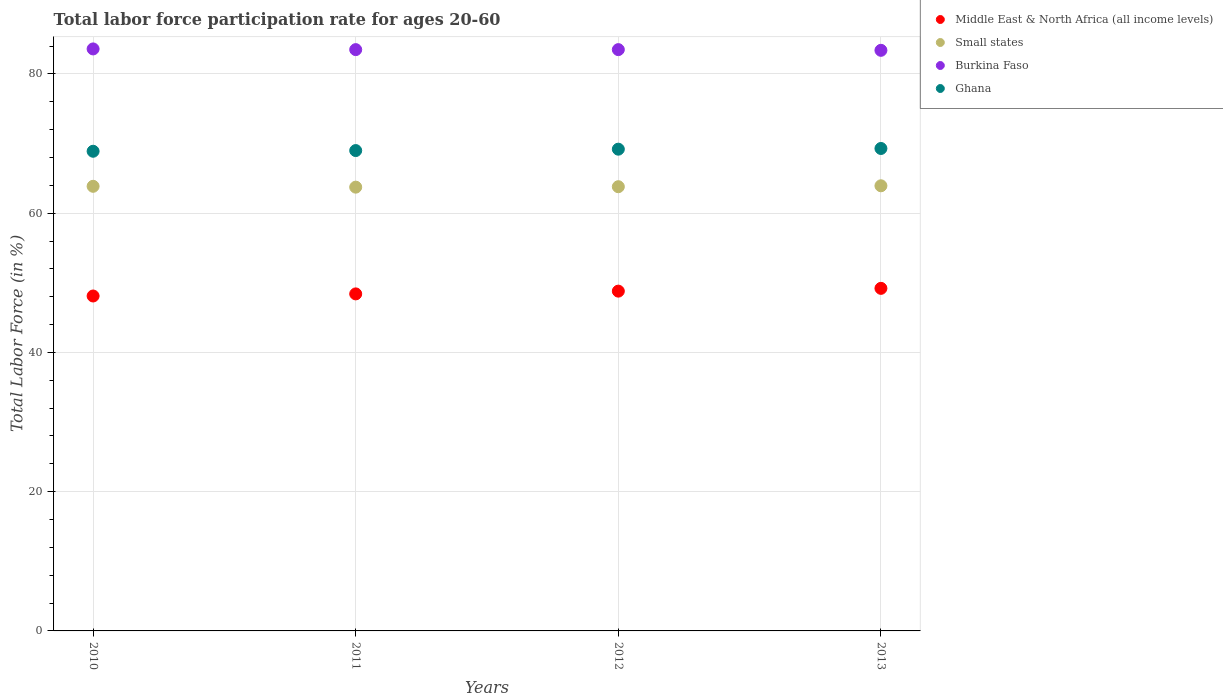What is the labor force participation rate in Ghana in 2012?
Give a very brief answer. 69.2. Across all years, what is the maximum labor force participation rate in Middle East & North Africa (all income levels)?
Offer a terse response. 49.21. Across all years, what is the minimum labor force participation rate in Ghana?
Provide a succinct answer. 68.9. In which year was the labor force participation rate in Middle East & North Africa (all income levels) maximum?
Your answer should be very brief. 2013. What is the total labor force participation rate in Ghana in the graph?
Make the answer very short. 276.4. What is the difference between the labor force participation rate in Burkina Faso in 2012 and that in 2013?
Make the answer very short. 0.1. What is the difference between the labor force participation rate in Small states in 2010 and the labor force participation rate in Middle East & North Africa (all income levels) in 2012?
Provide a succinct answer. 15.06. What is the average labor force participation rate in Small states per year?
Provide a succinct answer. 63.84. In the year 2010, what is the difference between the labor force participation rate in Small states and labor force participation rate in Ghana?
Make the answer very short. -5.03. What is the ratio of the labor force participation rate in Middle East & North Africa (all income levels) in 2010 to that in 2011?
Your answer should be very brief. 0.99. What is the difference between the highest and the second highest labor force participation rate in Small states?
Offer a very short reply. 0.07. What is the difference between the highest and the lowest labor force participation rate in Burkina Faso?
Offer a very short reply. 0.2. In how many years, is the labor force participation rate in Small states greater than the average labor force participation rate in Small states taken over all years?
Your answer should be very brief. 2. Is the sum of the labor force participation rate in Small states in 2010 and 2013 greater than the maximum labor force participation rate in Middle East & North Africa (all income levels) across all years?
Your answer should be compact. Yes. Is it the case that in every year, the sum of the labor force participation rate in Burkina Faso and labor force participation rate in Small states  is greater than the labor force participation rate in Middle East & North Africa (all income levels)?
Your answer should be compact. Yes. Does the labor force participation rate in Middle East & North Africa (all income levels) monotonically increase over the years?
Offer a very short reply. Yes. Is the labor force participation rate in Burkina Faso strictly greater than the labor force participation rate in Middle East & North Africa (all income levels) over the years?
Provide a succinct answer. Yes. Is the labor force participation rate in Burkina Faso strictly less than the labor force participation rate in Small states over the years?
Your answer should be very brief. No. How many dotlines are there?
Provide a succinct answer. 4. What is the difference between two consecutive major ticks on the Y-axis?
Offer a very short reply. 20. Does the graph contain any zero values?
Offer a very short reply. No. Where does the legend appear in the graph?
Offer a very short reply. Top right. What is the title of the graph?
Give a very brief answer. Total labor force participation rate for ages 20-60. What is the label or title of the X-axis?
Your answer should be very brief. Years. What is the label or title of the Y-axis?
Offer a terse response. Total Labor Force (in %). What is the Total Labor Force (in %) of Middle East & North Africa (all income levels) in 2010?
Offer a very short reply. 48.11. What is the Total Labor Force (in %) of Small states in 2010?
Your answer should be very brief. 63.87. What is the Total Labor Force (in %) of Burkina Faso in 2010?
Ensure brevity in your answer.  83.6. What is the Total Labor Force (in %) in Ghana in 2010?
Make the answer very short. 68.9. What is the Total Labor Force (in %) in Middle East & North Africa (all income levels) in 2011?
Ensure brevity in your answer.  48.41. What is the Total Labor Force (in %) in Small states in 2011?
Provide a short and direct response. 63.75. What is the Total Labor Force (in %) in Burkina Faso in 2011?
Your answer should be very brief. 83.5. What is the Total Labor Force (in %) of Ghana in 2011?
Make the answer very short. 69. What is the Total Labor Force (in %) of Middle East & North Africa (all income levels) in 2012?
Make the answer very short. 48.81. What is the Total Labor Force (in %) of Small states in 2012?
Offer a very short reply. 63.81. What is the Total Labor Force (in %) of Burkina Faso in 2012?
Keep it short and to the point. 83.5. What is the Total Labor Force (in %) of Ghana in 2012?
Offer a very short reply. 69.2. What is the Total Labor Force (in %) in Middle East & North Africa (all income levels) in 2013?
Your answer should be very brief. 49.21. What is the Total Labor Force (in %) in Small states in 2013?
Give a very brief answer. 63.94. What is the Total Labor Force (in %) in Burkina Faso in 2013?
Your answer should be compact. 83.4. What is the Total Labor Force (in %) in Ghana in 2013?
Give a very brief answer. 69.3. Across all years, what is the maximum Total Labor Force (in %) in Middle East & North Africa (all income levels)?
Keep it short and to the point. 49.21. Across all years, what is the maximum Total Labor Force (in %) of Small states?
Keep it short and to the point. 63.94. Across all years, what is the maximum Total Labor Force (in %) in Burkina Faso?
Give a very brief answer. 83.6. Across all years, what is the maximum Total Labor Force (in %) of Ghana?
Keep it short and to the point. 69.3. Across all years, what is the minimum Total Labor Force (in %) of Middle East & North Africa (all income levels)?
Provide a succinct answer. 48.11. Across all years, what is the minimum Total Labor Force (in %) in Small states?
Provide a short and direct response. 63.75. Across all years, what is the minimum Total Labor Force (in %) of Burkina Faso?
Provide a short and direct response. 83.4. Across all years, what is the minimum Total Labor Force (in %) in Ghana?
Ensure brevity in your answer.  68.9. What is the total Total Labor Force (in %) of Middle East & North Africa (all income levels) in the graph?
Provide a succinct answer. 194.54. What is the total Total Labor Force (in %) in Small states in the graph?
Offer a very short reply. 255.36. What is the total Total Labor Force (in %) in Burkina Faso in the graph?
Give a very brief answer. 334. What is the total Total Labor Force (in %) in Ghana in the graph?
Keep it short and to the point. 276.4. What is the difference between the Total Labor Force (in %) in Middle East & North Africa (all income levels) in 2010 and that in 2011?
Provide a succinct answer. -0.3. What is the difference between the Total Labor Force (in %) of Small states in 2010 and that in 2011?
Your answer should be compact. 0.12. What is the difference between the Total Labor Force (in %) in Middle East & North Africa (all income levels) in 2010 and that in 2012?
Give a very brief answer. -0.7. What is the difference between the Total Labor Force (in %) in Small states in 2010 and that in 2012?
Give a very brief answer. 0.06. What is the difference between the Total Labor Force (in %) of Middle East & North Africa (all income levels) in 2010 and that in 2013?
Offer a very short reply. -1.1. What is the difference between the Total Labor Force (in %) in Small states in 2010 and that in 2013?
Your answer should be very brief. -0.07. What is the difference between the Total Labor Force (in %) of Burkina Faso in 2010 and that in 2013?
Provide a succinct answer. 0.2. What is the difference between the Total Labor Force (in %) of Ghana in 2010 and that in 2013?
Your response must be concise. -0.4. What is the difference between the Total Labor Force (in %) of Middle East & North Africa (all income levels) in 2011 and that in 2012?
Offer a terse response. -0.4. What is the difference between the Total Labor Force (in %) in Small states in 2011 and that in 2012?
Make the answer very short. -0.06. What is the difference between the Total Labor Force (in %) in Burkina Faso in 2011 and that in 2012?
Offer a terse response. 0. What is the difference between the Total Labor Force (in %) in Middle East & North Africa (all income levels) in 2011 and that in 2013?
Keep it short and to the point. -0.8. What is the difference between the Total Labor Force (in %) in Small states in 2011 and that in 2013?
Provide a succinct answer. -0.2. What is the difference between the Total Labor Force (in %) in Burkina Faso in 2011 and that in 2013?
Offer a very short reply. 0.1. What is the difference between the Total Labor Force (in %) of Ghana in 2011 and that in 2013?
Provide a short and direct response. -0.3. What is the difference between the Total Labor Force (in %) in Middle East & North Africa (all income levels) in 2012 and that in 2013?
Ensure brevity in your answer.  -0.4. What is the difference between the Total Labor Force (in %) in Small states in 2012 and that in 2013?
Make the answer very short. -0.13. What is the difference between the Total Labor Force (in %) of Burkina Faso in 2012 and that in 2013?
Your answer should be compact. 0.1. What is the difference between the Total Labor Force (in %) in Ghana in 2012 and that in 2013?
Keep it short and to the point. -0.1. What is the difference between the Total Labor Force (in %) in Middle East & North Africa (all income levels) in 2010 and the Total Labor Force (in %) in Small states in 2011?
Your answer should be compact. -15.64. What is the difference between the Total Labor Force (in %) of Middle East & North Africa (all income levels) in 2010 and the Total Labor Force (in %) of Burkina Faso in 2011?
Keep it short and to the point. -35.39. What is the difference between the Total Labor Force (in %) in Middle East & North Africa (all income levels) in 2010 and the Total Labor Force (in %) in Ghana in 2011?
Make the answer very short. -20.89. What is the difference between the Total Labor Force (in %) in Small states in 2010 and the Total Labor Force (in %) in Burkina Faso in 2011?
Provide a succinct answer. -19.63. What is the difference between the Total Labor Force (in %) in Small states in 2010 and the Total Labor Force (in %) in Ghana in 2011?
Offer a very short reply. -5.13. What is the difference between the Total Labor Force (in %) in Middle East & North Africa (all income levels) in 2010 and the Total Labor Force (in %) in Small states in 2012?
Your response must be concise. -15.7. What is the difference between the Total Labor Force (in %) in Middle East & North Africa (all income levels) in 2010 and the Total Labor Force (in %) in Burkina Faso in 2012?
Keep it short and to the point. -35.39. What is the difference between the Total Labor Force (in %) in Middle East & North Africa (all income levels) in 2010 and the Total Labor Force (in %) in Ghana in 2012?
Your response must be concise. -21.09. What is the difference between the Total Labor Force (in %) in Small states in 2010 and the Total Labor Force (in %) in Burkina Faso in 2012?
Ensure brevity in your answer.  -19.63. What is the difference between the Total Labor Force (in %) of Small states in 2010 and the Total Labor Force (in %) of Ghana in 2012?
Offer a terse response. -5.33. What is the difference between the Total Labor Force (in %) of Middle East & North Africa (all income levels) in 2010 and the Total Labor Force (in %) of Small states in 2013?
Ensure brevity in your answer.  -15.83. What is the difference between the Total Labor Force (in %) in Middle East & North Africa (all income levels) in 2010 and the Total Labor Force (in %) in Burkina Faso in 2013?
Provide a succinct answer. -35.29. What is the difference between the Total Labor Force (in %) of Middle East & North Africa (all income levels) in 2010 and the Total Labor Force (in %) of Ghana in 2013?
Provide a succinct answer. -21.19. What is the difference between the Total Labor Force (in %) in Small states in 2010 and the Total Labor Force (in %) in Burkina Faso in 2013?
Make the answer very short. -19.53. What is the difference between the Total Labor Force (in %) in Small states in 2010 and the Total Labor Force (in %) in Ghana in 2013?
Provide a short and direct response. -5.43. What is the difference between the Total Labor Force (in %) in Burkina Faso in 2010 and the Total Labor Force (in %) in Ghana in 2013?
Your response must be concise. 14.3. What is the difference between the Total Labor Force (in %) in Middle East & North Africa (all income levels) in 2011 and the Total Labor Force (in %) in Small states in 2012?
Offer a terse response. -15.4. What is the difference between the Total Labor Force (in %) in Middle East & North Africa (all income levels) in 2011 and the Total Labor Force (in %) in Burkina Faso in 2012?
Provide a succinct answer. -35.09. What is the difference between the Total Labor Force (in %) in Middle East & North Africa (all income levels) in 2011 and the Total Labor Force (in %) in Ghana in 2012?
Offer a very short reply. -20.79. What is the difference between the Total Labor Force (in %) in Small states in 2011 and the Total Labor Force (in %) in Burkina Faso in 2012?
Give a very brief answer. -19.75. What is the difference between the Total Labor Force (in %) of Small states in 2011 and the Total Labor Force (in %) of Ghana in 2012?
Provide a succinct answer. -5.45. What is the difference between the Total Labor Force (in %) of Burkina Faso in 2011 and the Total Labor Force (in %) of Ghana in 2012?
Provide a short and direct response. 14.3. What is the difference between the Total Labor Force (in %) in Middle East & North Africa (all income levels) in 2011 and the Total Labor Force (in %) in Small states in 2013?
Your answer should be very brief. -15.53. What is the difference between the Total Labor Force (in %) in Middle East & North Africa (all income levels) in 2011 and the Total Labor Force (in %) in Burkina Faso in 2013?
Give a very brief answer. -34.99. What is the difference between the Total Labor Force (in %) of Middle East & North Africa (all income levels) in 2011 and the Total Labor Force (in %) of Ghana in 2013?
Provide a succinct answer. -20.89. What is the difference between the Total Labor Force (in %) of Small states in 2011 and the Total Labor Force (in %) of Burkina Faso in 2013?
Offer a very short reply. -19.65. What is the difference between the Total Labor Force (in %) in Small states in 2011 and the Total Labor Force (in %) in Ghana in 2013?
Your answer should be very brief. -5.55. What is the difference between the Total Labor Force (in %) of Middle East & North Africa (all income levels) in 2012 and the Total Labor Force (in %) of Small states in 2013?
Your answer should be very brief. -15.13. What is the difference between the Total Labor Force (in %) in Middle East & North Africa (all income levels) in 2012 and the Total Labor Force (in %) in Burkina Faso in 2013?
Provide a succinct answer. -34.59. What is the difference between the Total Labor Force (in %) in Middle East & North Africa (all income levels) in 2012 and the Total Labor Force (in %) in Ghana in 2013?
Offer a terse response. -20.49. What is the difference between the Total Labor Force (in %) of Small states in 2012 and the Total Labor Force (in %) of Burkina Faso in 2013?
Provide a short and direct response. -19.59. What is the difference between the Total Labor Force (in %) in Small states in 2012 and the Total Labor Force (in %) in Ghana in 2013?
Your answer should be compact. -5.49. What is the average Total Labor Force (in %) in Middle East & North Africa (all income levels) per year?
Ensure brevity in your answer.  48.63. What is the average Total Labor Force (in %) of Small states per year?
Give a very brief answer. 63.84. What is the average Total Labor Force (in %) of Burkina Faso per year?
Provide a short and direct response. 83.5. What is the average Total Labor Force (in %) of Ghana per year?
Make the answer very short. 69.1. In the year 2010, what is the difference between the Total Labor Force (in %) of Middle East & North Africa (all income levels) and Total Labor Force (in %) of Small states?
Your answer should be very brief. -15.76. In the year 2010, what is the difference between the Total Labor Force (in %) in Middle East & North Africa (all income levels) and Total Labor Force (in %) in Burkina Faso?
Provide a succinct answer. -35.49. In the year 2010, what is the difference between the Total Labor Force (in %) in Middle East & North Africa (all income levels) and Total Labor Force (in %) in Ghana?
Your answer should be very brief. -20.79. In the year 2010, what is the difference between the Total Labor Force (in %) in Small states and Total Labor Force (in %) in Burkina Faso?
Ensure brevity in your answer.  -19.73. In the year 2010, what is the difference between the Total Labor Force (in %) of Small states and Total Labor Force (in %) of Ghana?
Offer a terse response. -5.03. In the year 2010, what is the difference between the Total Labor Force (in %) in Burkina Faso and Total Labor Force (in %) in Ghana?
Your response must be concise. 14.7. In the year 2011, what is the difference between the Total Labor Force (in %) of Middle East & North Africa (all income levels) and Total Labor Force (in %) of Small states?
Keep it short and to the point. -15.33. In the year 2011, what is the difference between the Total Labor Force (in %) of Middle East & North Africa (all income levels) and Total Labor Force (in %) of Burkina Faso?
Your answer should be compact. -35.09. In the year 2011, what is the difference between the Total Labor Force (in %) of Middle East & North Africa (all income levels) and Total Labor Force (in %) of Ghana?
Ensure brevity in your answer.  -20.59. In the year 2011, what is the difference between the Total Labor Force (in %) of Small states and Total Labor Force (in %) of Burkina Faso?
Your answer should be compact. -19.75. In the year 2011, what is the difference between the Total Labor Force (in %) in Small states and Total Labor Force (in %) in Ghana?
Make the answer very short. -5.25. In the year 2012, what is the difference between the Total Labor Force (in %) in Middle East & North Africa (all income levels) and Total Labor Force (in %) in Small states?
Offer a terse response. -15. In the year 2012, what is the difference between the Total Labor Force (in %) in Middle East & North Africa (all income levels) and Total Labor Force (in %) in Burkina Faso?
Make the answer very short. -34.69. In the year 2012, what is the difference between the Total Labor Force (in %) of Middle East & North Africa (all income levels) and Total Labor Force (in %) of Ghana?
Provide a short and direct response. -20.39. In the year 2012, what is the difference between the Total Labor Force (in %) in Small states and Total Labor Force (in %) in Burkina Faso?
Offer a very short reply. -19.69. In the year 2012, what is the difference between the Total Labor Force (in %) in Small states and Total Labor Force (in %) in Ghana?
Give a very brief answer. -5.39. In the year 2013, what is the difference between the Total Labor Force (in %) of Middle East & North Africa (all income levels) and Total Labor Force (in %) of Small states?
Provide a short and direct response. -14.73. In the year 2013, what is the difference between the Total Labor Force (in %) in Middle East & North Africa (all income levels) and Total Labor Force (in %) in Burkina Faso?
Your answer should be very brief. -34.19. In the year 2013, what is the difference between the Total Labor Force (in %) in Middle East & North Africa (all income levels) and Total Labor Force (in %) in Ghana?
Your answer should be very brief. -20.09. In the year 2013, what is the difference between the Total Labor Force (in %) of Small states and Total Labor Force (in %) of Burkina Faso?
Offer a very short reply. -19.46. In the year 2013, what is the difference between the Total Labor Force (in %) of Small states and Total Labor Force (in %) of Ghana?
Give a very brief answer. -5.36. What is the ratio of the Total Labor Force (in %) of Burkina Faso in 2010 to that in 2011?
Your response must be concise. 1. What is the ratio of the Total Labor Force (in %) of Ghana in 2010 to that in 2011?
Offer a terse response. 1. What is the ratio of the Total Labor Force (in %) of Middle East & North Africa (all income levels) in 2010 to that in 2012?
Offer a terse response. 0.99. What is the ratio of the Total Labor Force (in %) of Ghana in 2010 to that in 2012?
Offer a terse response. 1. What is the ratio of the Total Labor Force (in %) in Middle East & North Africa (all income levels) in 2010 to that in 2013?
Provide a succinct answer. 0.98. What is the ratio of the Total Labor Force (in %) in Small states in 2010 to that in 2013?
Provide a succinct answer. 1. What is the ratio of the Total Labor Force (in %) of Ghana in 2010 to that in 2013?
Make the answer very short. 0.99. What is the ratio of the Total Labor Force (in %) of Middle East & North Africa (all income levels) in 2011 to that in 2012?
Ensure brevity in your answer.  0.99. What is the ratio of the Total Labor Force (in %) of Ghana in 2011 to that in 2012?
Provide a short and direct response. 1. What is the ratio of the Total Labor Force (in %) of Middle East & North Africa (all income levels) in 2011 to that in 2013?
Offer a terse response. 0.98. What is the ratio of the Total Labor Force (in %) of Burkina Faso in 2011 to that in 2013?
Your response must be concise. 1. What is the ratio of the Total Labor Force (in %) of Middle East & North Africa (all income levels) in 2012 to that in 2013?
Your answer should be very brief. 0.99. What is the ratio of the Total Labor Force (in %) in Burkina Faso in 2012 to that in 2013?
Ensure brevity in your answer.  1. What is the ratio of the Total Labor Force (in %) in Ghana in 2012 to that in 2013?
Offer a terse response. 1. What is the difference between the highest and the second highest Total Labor Force (in %) of Middle East & North Africa (all income levels)?
Give a very brief answer. 0.4. What is the difference between the highest and the second highest Total Labor Force (in %) in Small states?
Ensure brevity in your answer.  0.07. What is the difference between the highest and the second highest Total Labor Force (in %) of Burkina Faso?
Give a very brief answer. 0.1. What is the difference between the highest and the second highest Total Labor Force (in %) of Ghana?
Give a very brief answer. 0.1. What is the difference between the highest and the lowest Total Labor Force (in %) in Middle East & North Africa (all income levels)?
Provide a succinct answer. 1.1. What is the difference between the highest and the lowest Total Labor Force (in %) of Small states?
Offer a terse response. 0.2. What is the difference between the highest and the lowest Total Labor Force (in %) of Burkina Faso?
Keep it short and to the point. 0.2. 